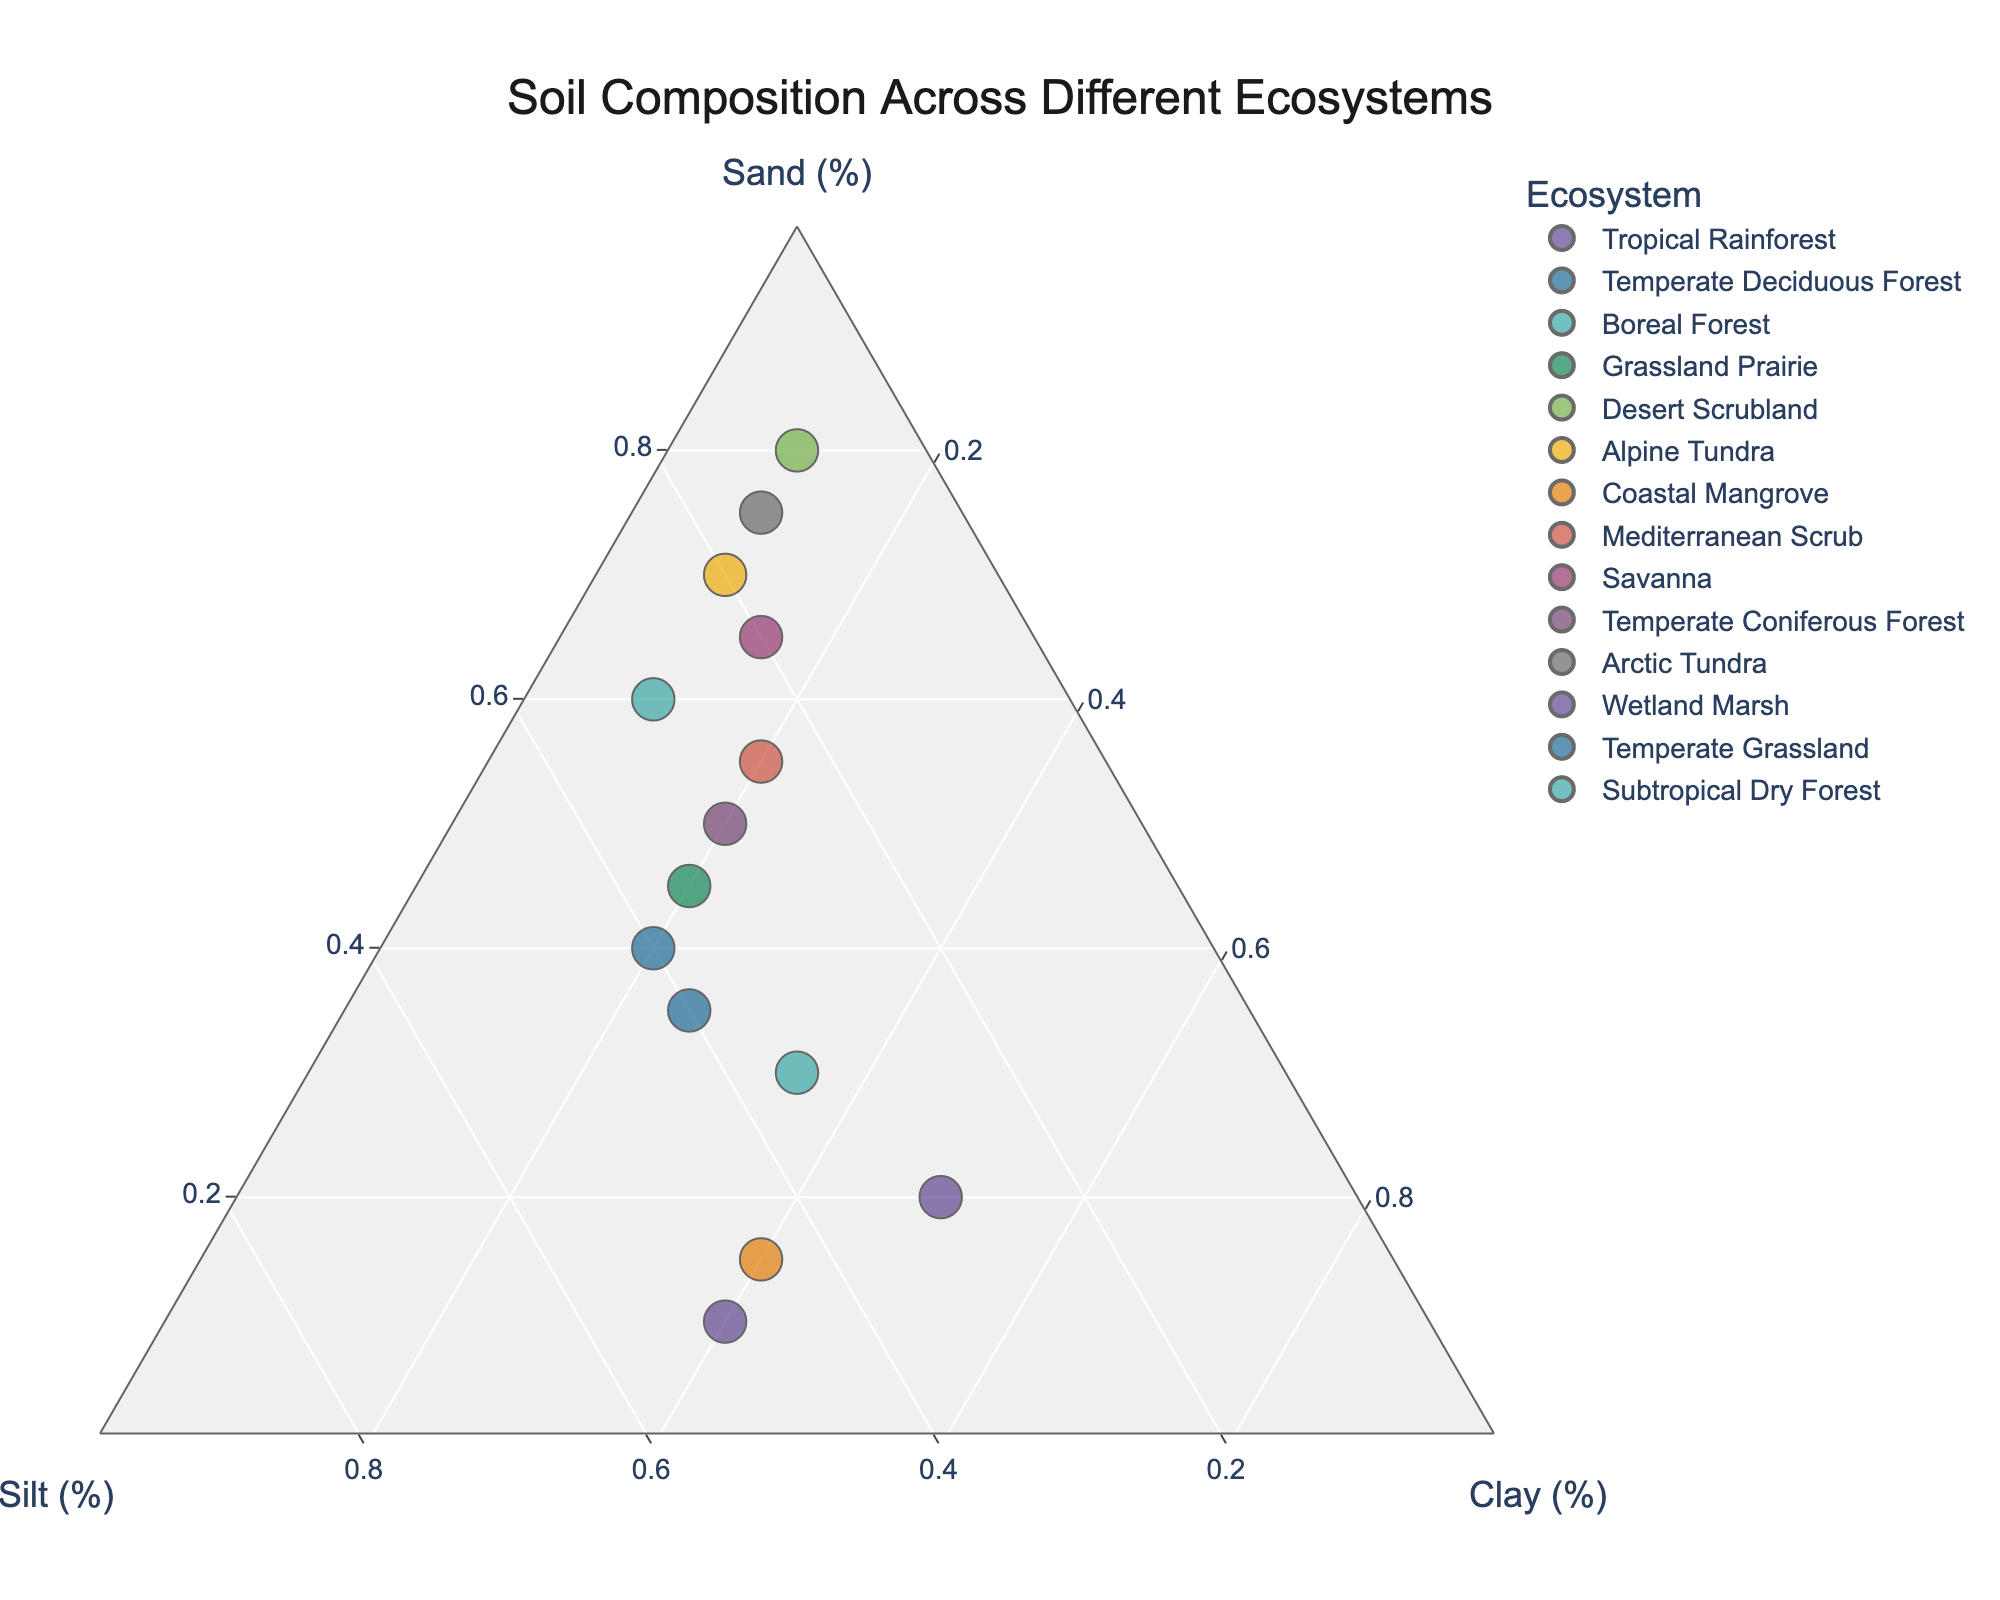What's the title of the ternary plot? The title is usually located at the top center of the plot.
Answer: Soil Composition Across Different Ecosystems Which ecosystem has the highest percentage of sand? By examining the location of the points on the ternary plot, the point furthest along the sand axis has the highest sand content. The Desert Scrubland has 80% sand.
Answer: Desert Scrubland How many ecosystems have a clay content equal to or greater than 40%? Check the clay axis and find the points that are positioned at or above the 40% mark. Coastal Mangrove and Wetland Marsh have 40% clay content each.
Answer: 2 What is the combined percentage of sand and silt for the Temperate Deciduous Forest? Add the sand and silt percentages for Temperate Deciduous Forest (35% sand, 40% silt).
Answer: 75% Which ecosystem has the lowest percentage of silt and what is that percentage? Look for the point that is closest to the sand-clay axis, indicating low silt content. The Desert Scrubland has 10% silt.
Answer: Desert Scrubland, 10% Is the sand content in the Temperate Grassland higher than in the Alpine Tundra? Compare the sand percentages of Temperate Grassland (40%) and Alpine Tundra (70%).
Answer: No What is the average clay percentage across all listed ecosystems? Sum all clay percentages and divide by the number of ecosystems (14). (50+25+10+20+10+10+40+20+15+20+10+40+20+35)/14 = 22.86
Answer: 22.86% Do more ecosystems have a sand content above or below 50%? Count the number of ecosystems with over 50% sand content and those with 50% or less. 6 ecosystems have more than 50% sand, and 8 ecosystems have 50% or less.
Answer: Below Which ecosystem is closest to the centroid of the ternary plot? The centroid of the ternary plot is at (33.33, 33.33, 33.33). The Subtropical Dry Forest with values (30, 35, 35) is closest to these values.
Answer: Subtropical Dry Forest How does the Savanna's soil composition compare to the Boreal Forest? Check percentages of sand, silt, and clay for both ecosystems. Savanna: (65% sand, 20% silt, 15% clay); Boreal Forest: (60% sand, 30% silt, 10% clay). Savanna has higher sand and clay but lower silt.
Answer: Savanna has higher sand and clay, lower silt 